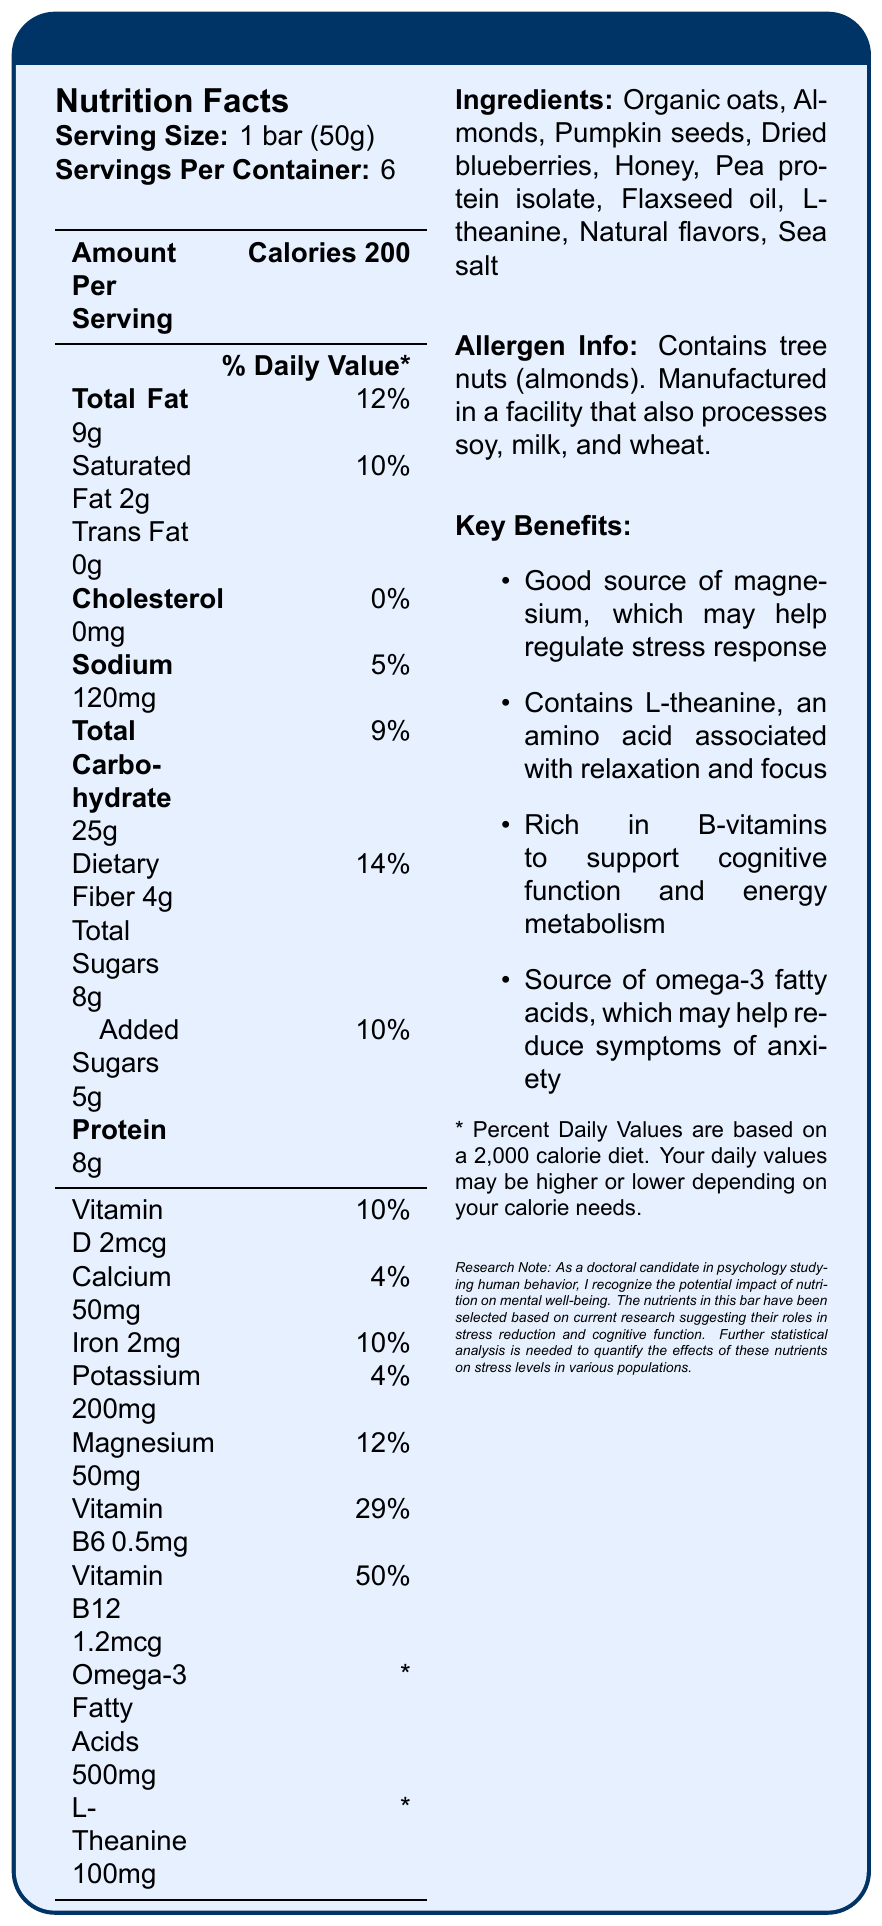what is the serving size of the MindEase Stress Relief Bar? The serving size is explicitly mentioned as "1 bar (50g)" in the document.
Answer: 1 bar (50g) how many servings are contained in one package? The document states that there are "Servings Per Container: 6".
Answer: 6 how much magnesium is in one serving of the bar? The amount of magnesium per serving is listed as "50mg" in the nutrition facts.
Answer: 50mg what is the percentage daily value of vitamin B6 in the bar? The percentage daily value of vitamin B6 is specifically listed as "29%" per serving.
Answer: 29% how many grams of dietary fiber are in one serving? The document states that each serving contains "4g" of dietary fiber.
Answer: 4g which ingredient is NOT listed in the MindEase Stress Relief Bar? 
A. Organic oats
B. Almonds
C. Pea protein isolate
D. Dark chocolate
E. Honey The list of ingredients includes Organic oats, Almonds, Pumpkin seeds, Dried blueberries, Honey, Pea protein isolate, Flaxseed oil, L-theanine, Natural flavors, and Sea salt. Dark chocolate is not listed.
Answer: D. Dark chocolate how many grams of protein are there in one serving? 
1. 4g
2. 8g
3. 12g
4. 16g The document lists "8g" of protein per serving.
Answer: 2. 8g does the MindEase Stress Relief Bar contain any trans fat? The nutrition facts panel states "Trans Fat 0g," indicating there is no trans fat in the bar.
Answer: No summarize the key benefits of the MindEase Stress Relief Bar. The document mentions that these benefits are backed by the nutrient composition of the bar and align with current research on stress reduction and cognitive function.
Answer: The MindEase Stress Relief Bar offers several benefits: it is a good source of magnesium, which may help regulate stress response; it contains L-theanine for relaxation and focus; it is rich in B-vitamins to support cognitive function and energy metabolism; it is also a source of omega-3 fatty acids, which may help reduce symptoms of anxiety. provide the amount of vitamin B12 in one serving. The amount of vitamin B12 in one serving is listed as "1.2mcg" in the nutrition facts section.
Answer: 1.2mcg are almonds included in the ingredients of the bar? Almonds are listed in the ingredient list of the bar.
Answer: Yes what is the total carbohydrate content per serving? The document states that the total carbohydrate content per serving is "25g."
Answer: 25g where is the product manufactured? The document does not provide information about the specific location where the product is manufactured.
Answer: Not enough information 